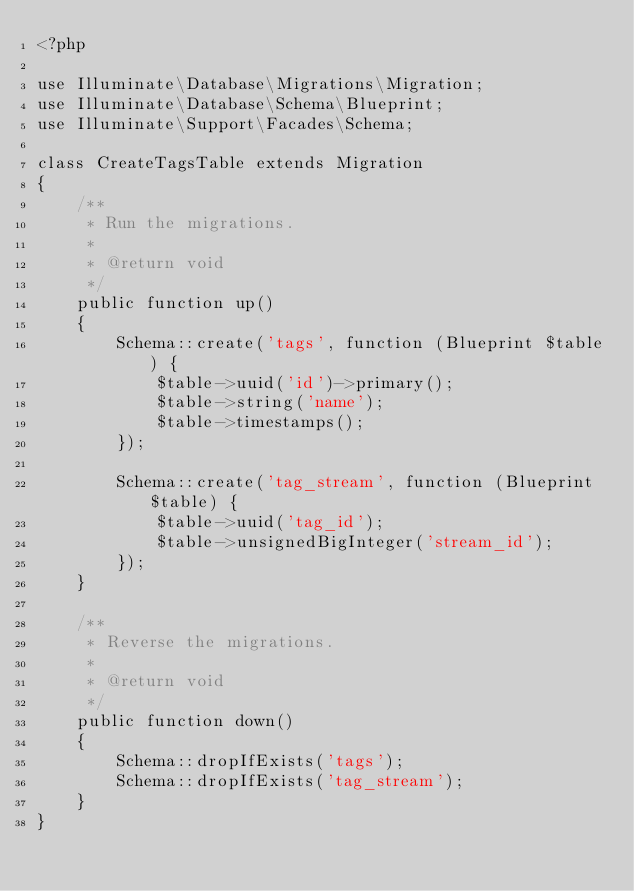<code> <loc_0><loc_0><loc_500><loc_500><_PHP_><?php

use Illuminate\Database\Migrations\Migration;
use Illuminate\Database\Schema\Blueprint;
use Illuminate\Support\Facades\Schema;

class CreateTagsTable extends Migration
{
    /**
     * Run the migrations.
     *
     * @return void
     */
    public function up()
    {
        Schema::create('tags', function (Blueprint $table) {
            $table->uuid('id')->primary();
            $table->string('name');
            $table->timestamps();
        });

        Schema::create('tag_stream', function (Blueprint $table) {
            $table->uuid('tag_id');
            $table->unsignedBigInteger('stream_id');
        });
    }

    /**
     * Reverse the migrations.
     *
     * @return void
     */
    public function down()
    {
        Schema::dropIfExists('tags');
        Schema::dropIfExists('tag_stream');
    }
}
</code> 